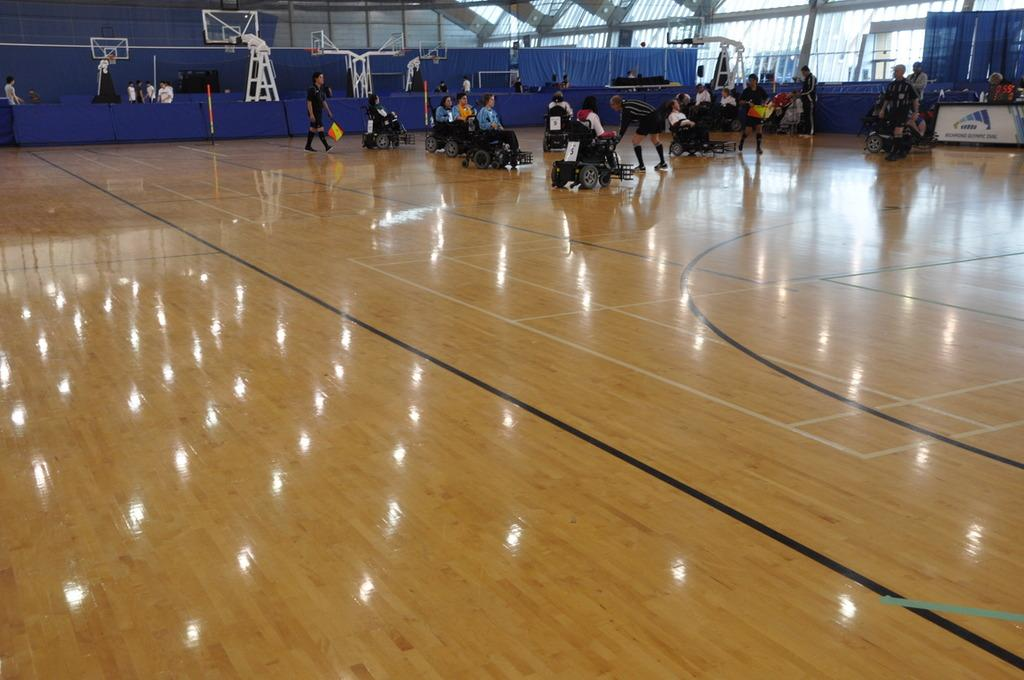What are the people in the image doing? There is a group of people sitting on wheelchairs and people standing in the image. What can be seen in the background of the image? There are blue-colored curtains in the background of the image. What type of bell can be heard ringing in the image? There is no bell present or ringing in the image. How is the group of people divided in the image? The image does not show any division among the group of people; they are all together. 